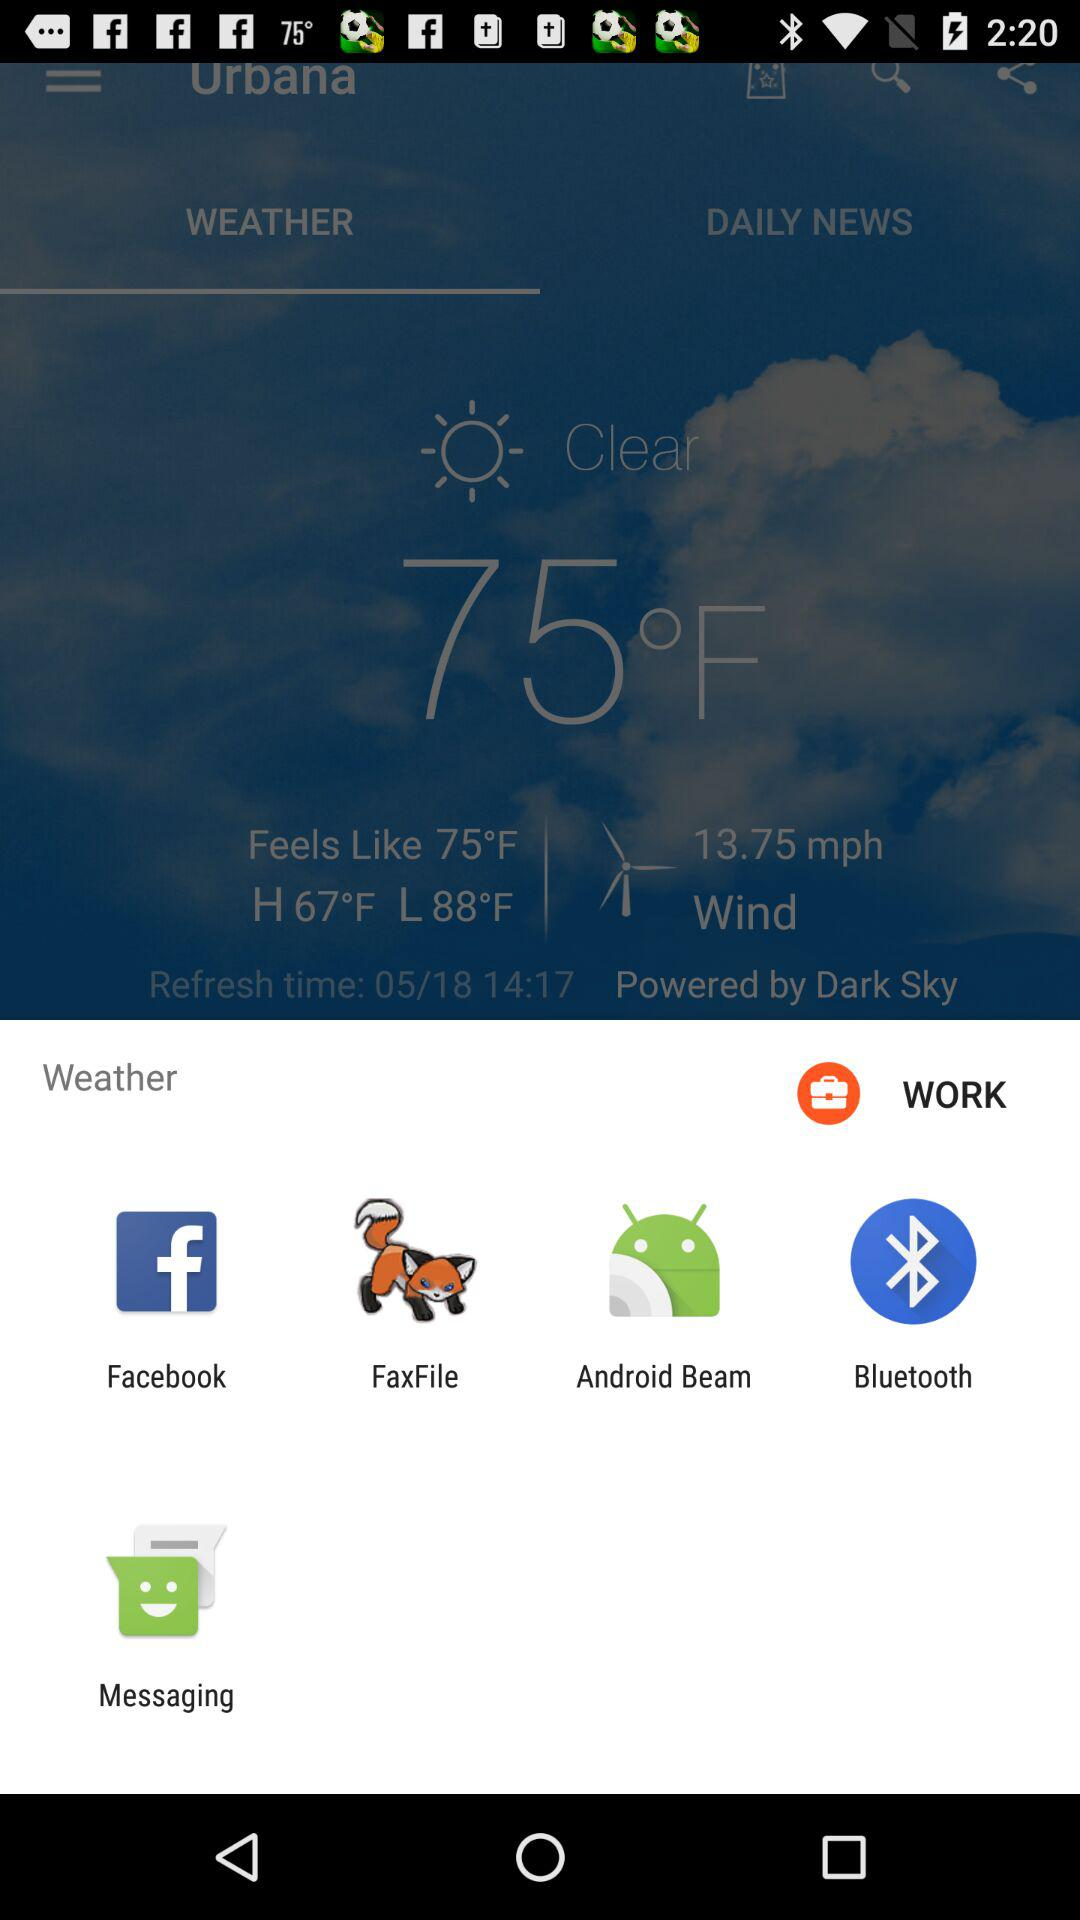What is the speed of the wind? The speed of the wind is 13.75 mph. 